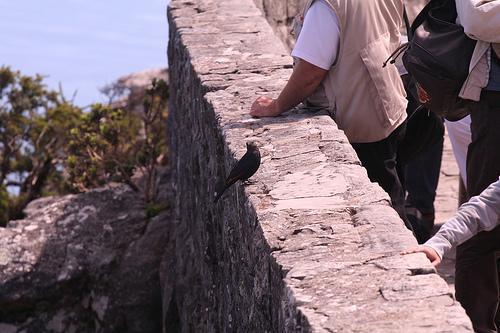How many people are there?
Give a very brief answer. 4. 